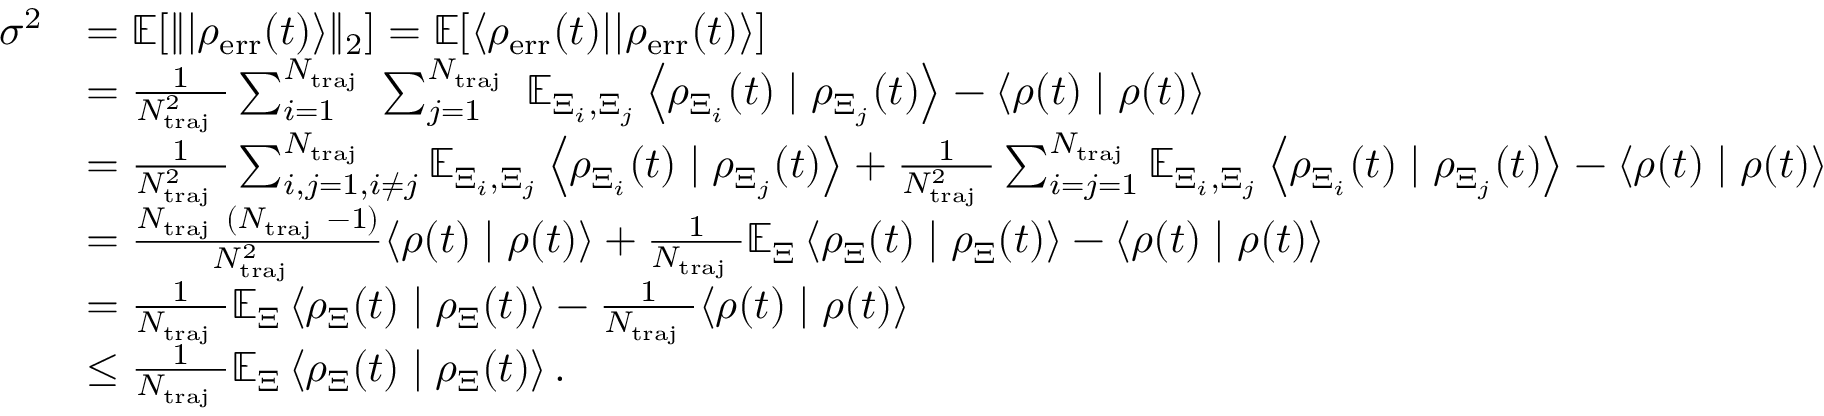<formula> <loc_0><loc_0><loc_500><loc_500>\begin{array} { r l } { \sigma ^ { 2 } } & { = \mathbb { E } [ \| | \rho _ { e r r } ( t ) \rangle \| _ { 2 } ] = \mathbb { E } [ \langle \rho _ { e r r } ( t ) | | \rho _ { e r r } ( t ) \rangle ] } \\ & { = \frac { 1 } { N _ { t r a j } ^ { 2 } } \sum _ { i = 1 } ^ { N _ { t r a j } } \sum _ { j = 1 } ^ { N _ { t r a j } } \mathbb { E } _ { \Xi _ { i } , \Xi _ { j } } \left \langle \rho _ { \Xi _ { i } } ( t ) | \rho _ { \Xi _ { j } } ( t ) \right \rangle - \langle \rho ( t ) | \rho ( t ) \rangle } \\ & { = \frac { 1 } { N _ { t r a j } ^ { 2 } } \sum _ { i , j = 1 , i \neq j } ^ { N _ { t r a j } } \mathbb { E } _ { \Xi _ { i } , \Xi _ { j } } \left \langle \rho _ { \Xi _ { i } } ( t ) | \rho _ { \Xi _ { j } } ( t ) \right \rangle + \frac { 1 } { N _ { t r a j } ^ { 2 } } \sum _ { i = j = 1 } ^ { N _ { t r a j } } \mathbb { E } _ { \Xi _ { i } , \Xi _ { j } } \left \langle \rho _ { \Xi _ { i } } ( t ) | \rho _ { \Xi _ { j } } ( t ) \right \rangle - \langle \rho ( t ) | \rho ( t ) \rangle } \\ & { = \frac { N _ { t r a j } ( N _ { t r a j } - 1 ) } { N _ { t r a j } ^ { 2 } } \langle \rho ( t ) | \rho ( t ) \rangle + \frac { 1 } { N _ { t r a j } } \mathbb { E } _ { \Xi } \left \langle \rho _ { \Xi } ( t ) | \rho _ { \Xi } ( t ) \right \rangle - \langle \rho ( t ) | \rho ( t ) \rangle } \\ & { = \frac { 1 } { N _ { t r a j } } \mathbb { E } _ { \Xi } \left \langle \rho _ { \Xi } ( t ) | \rho _ { \Xi } ( t ) \right \rangle - \frac { 1 } { N _ { t r a j } } \langle \rho ( t ) | \rho ( t ) \rangle } \\ & { \leq \frac { 1 } { N _ { t r a j } } \mathbb { E } _ { \Xi } \left \langle \rho _ { \Xi } ( t ) | \rho _ { \Xi } ( t ) \right \rangle . } \end{array}</formula> 